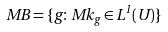Convert formula to latex. <formula><loc_0><loc_0><loc_500><loc_500>M B = \{ g \colon M k _ { g } \in L ^ { 1 } ( U ) \}</formula> 